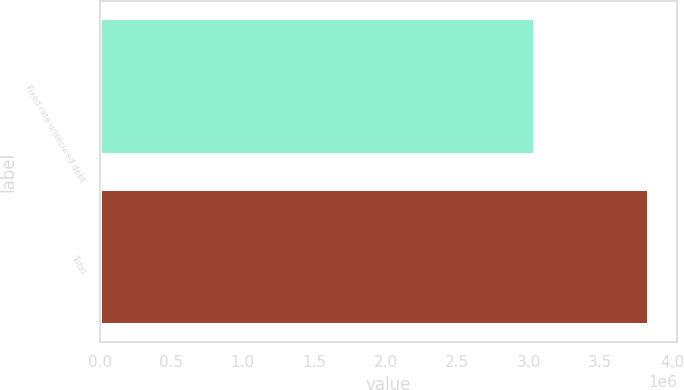Convert chart to OTSL. <chart><loc_0><loc_0><loc_500><loc_500><bar_chart><fcel>Fixed rate unsecured debt<fcel>Total<nl><fcel>3.04223e+06<fcel>3.84162e+06<nl></chart> 